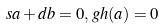<formula> <loc_0><loc_0><loc_500><loc_500>s a + d b = 0 , \, g h ( a ) = 0</formula> 